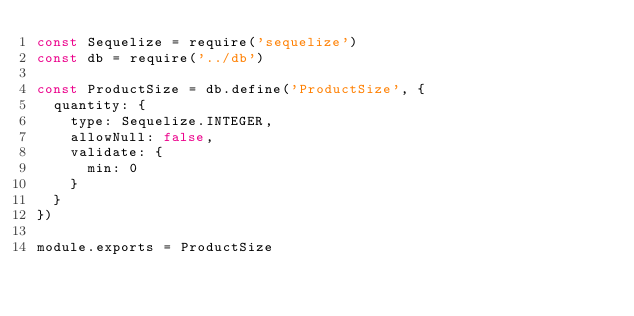Convert code to text. <code><loc_0><loc_0><loc_500><loc_500><_JavaScript_>const Sequelize = require('sequelize')
const db = require('../db')

const ProductSize = db.define('ProductSize', {
  quantity: {
    type: Sequelize.INTEGER,
    allowNull: false,
    validate: {
      min: 0
    }
  }
})

module.exports = ProductSize
</code> 